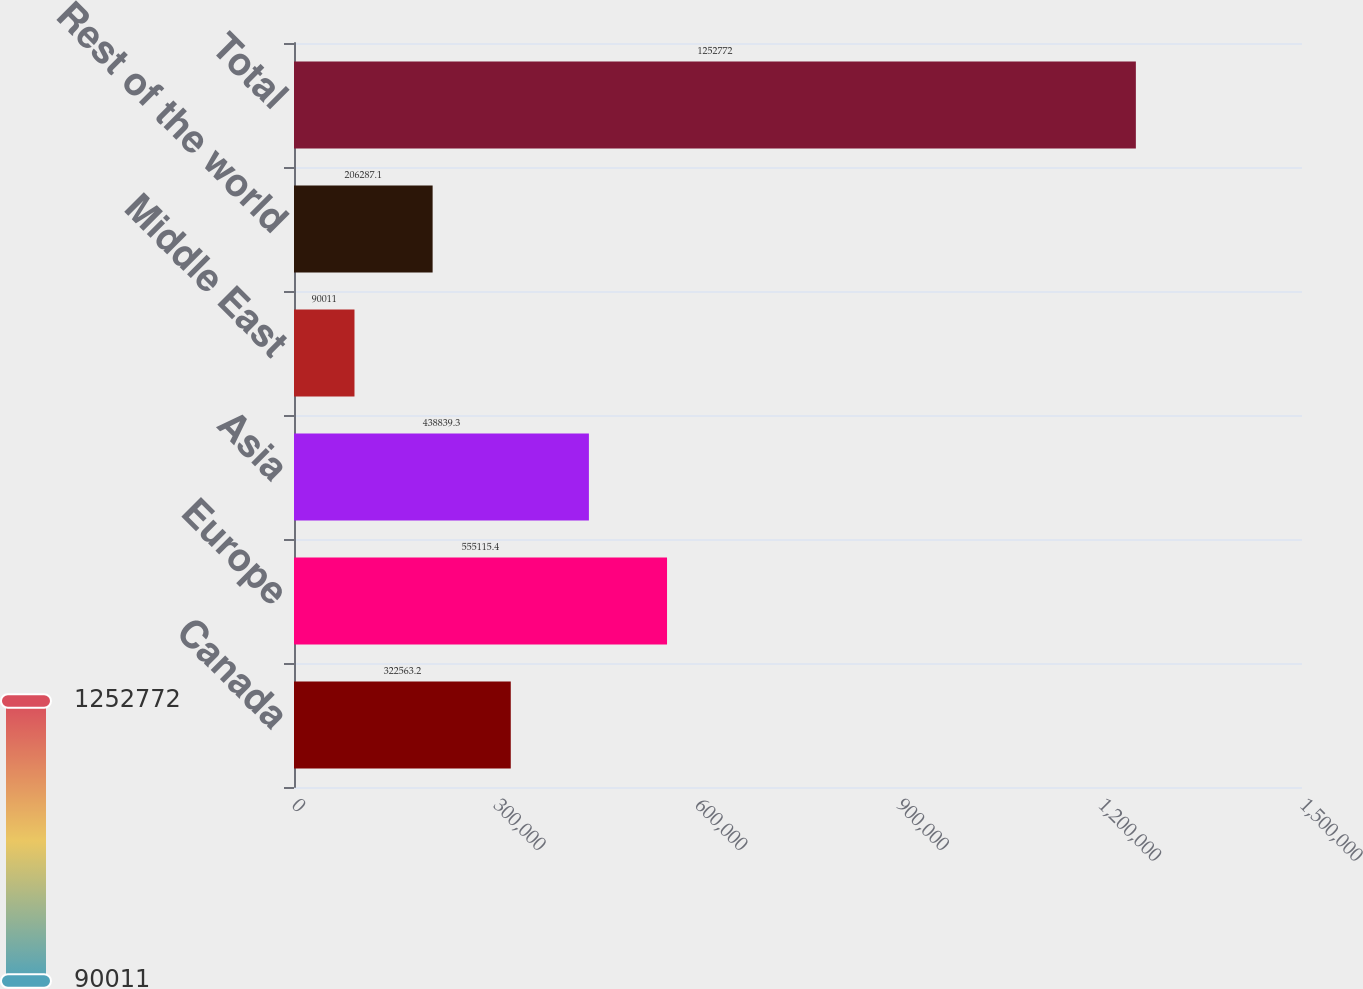Convert chart to OTSL. <chart><loc_0><loc_0><loc_500><loc_500><bar_chart><fcel>Canada<fcel>Europe<fcel>Asia<fcel>Middle East<fcel>Rest of the world<fcel>Total<nl><fcel>322563<fcel>555115<fcel>438839<fcel>90011<fcel>206287<fcel>1.25277e+06<nl></chart> 